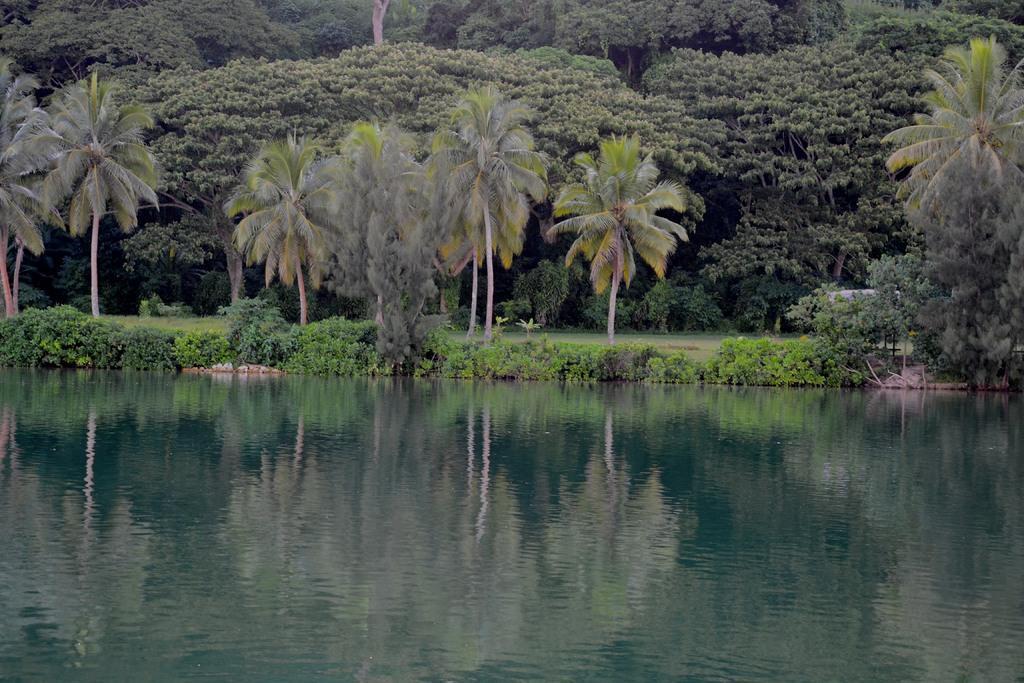Could you give a brief overview of what you see in this image? In the foreground of this picture, there is water. In the background, there are trees and plants. 